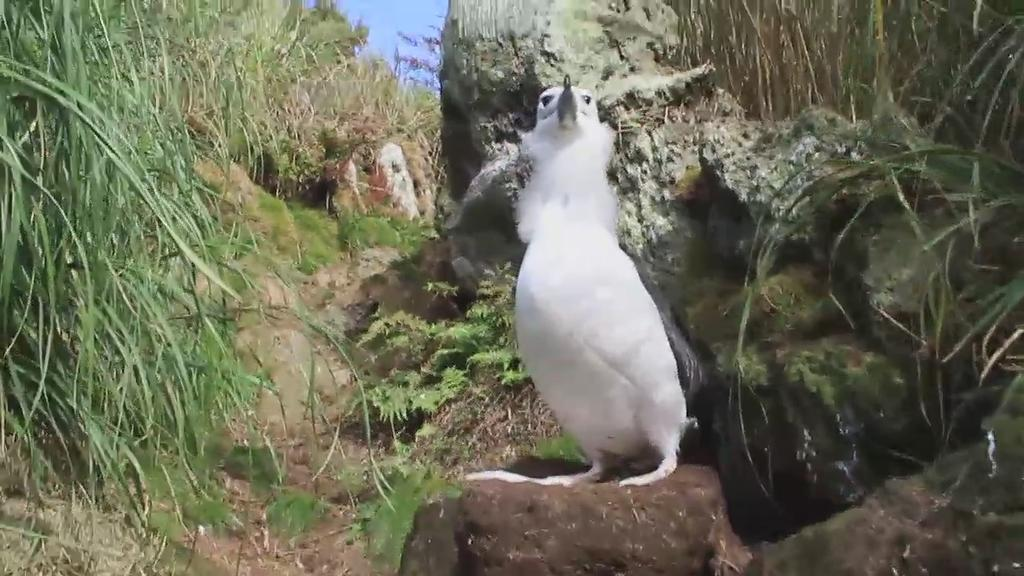What type of animal can be seen in the image? There is a bird in the image. What type of natural features are present in the image? There are rocks, grass, and plants in the image. What part of the natural environment is visible in the image? The sky is visible in the image. What type of rice is being served in the school cafeteria in the image? There is no school or rice present in the image; it features a bird and natural features. 